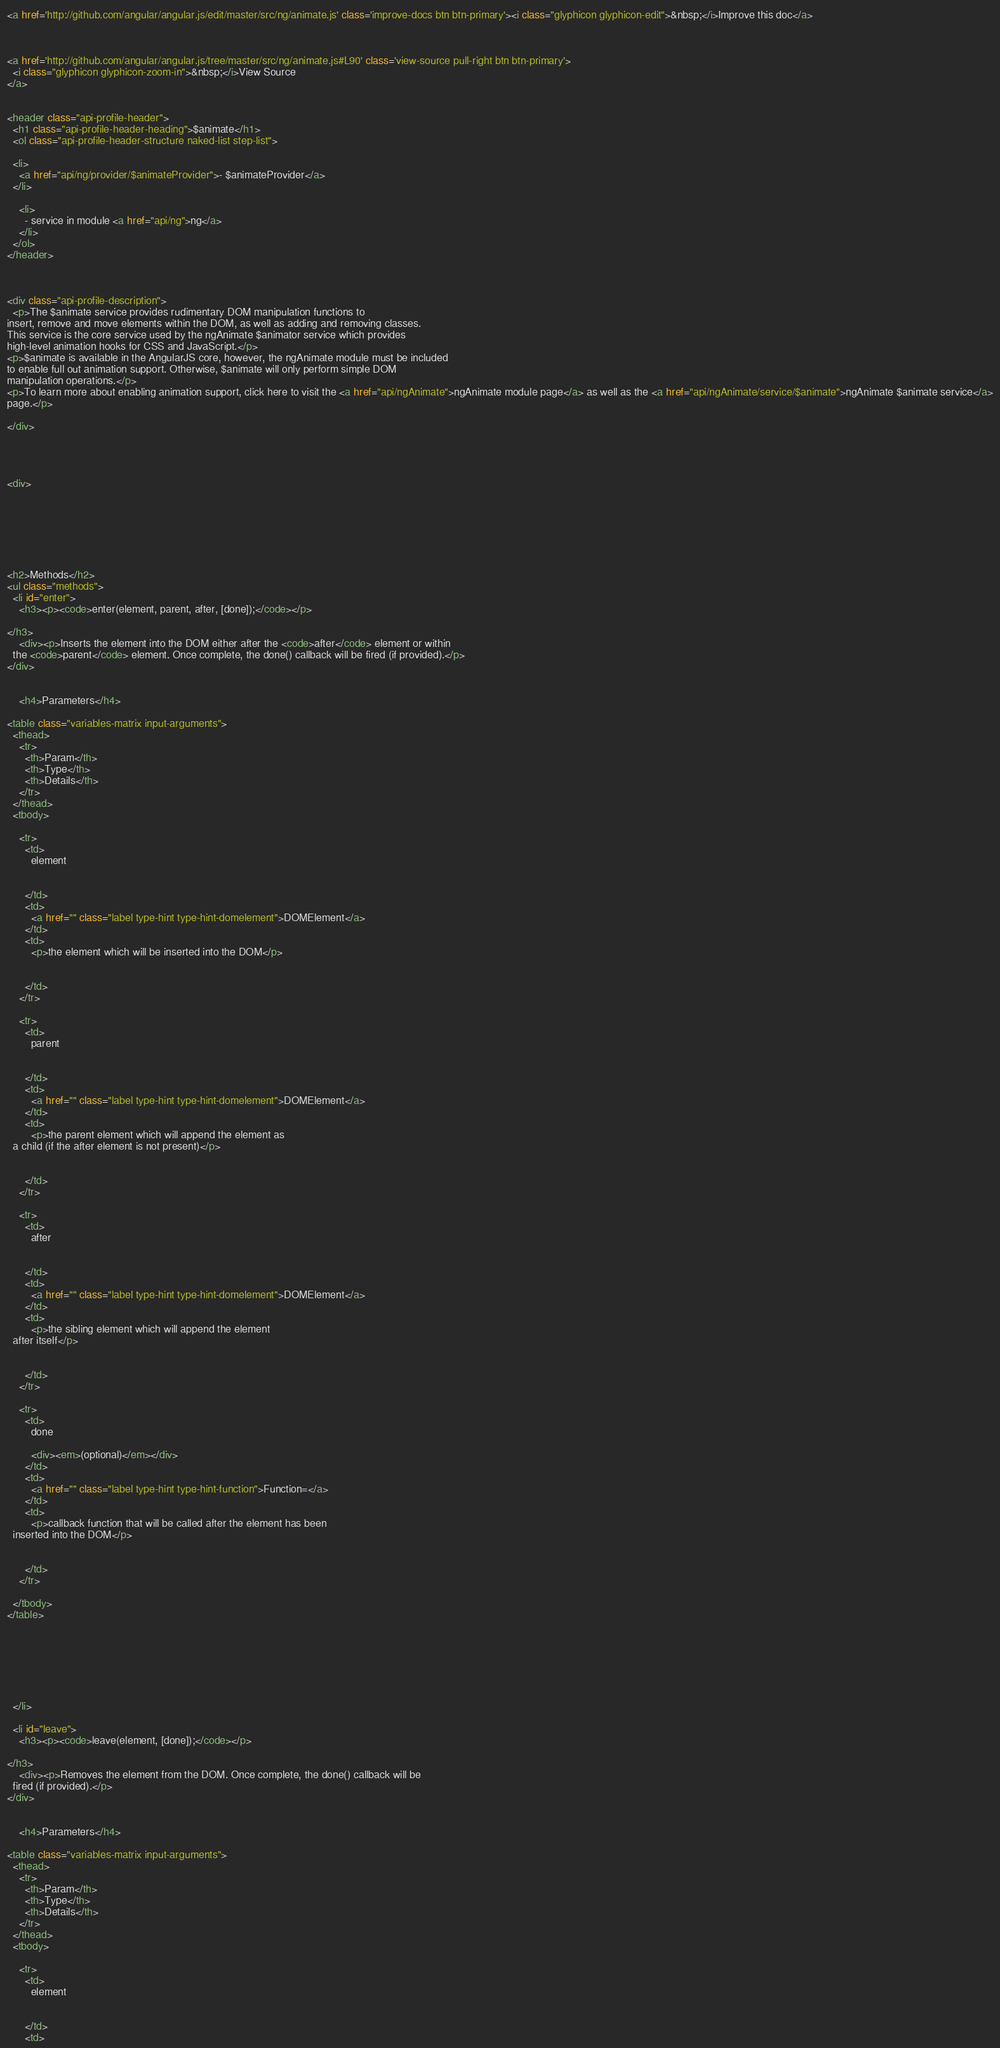Convert code to text. <code><loc_0><loc_0><loc_500><loc_500><_HTML_><a href='http://github.com/angular/angular.js/edit/master/src/ng/animate.js' class='improve-docs btn btn-primary'><i class="glyphicon glyphicon-edit">&nbsp;</i>Improve this doc</a>



<a href='http://github.com/angular/angular.js/tree/master/src/ng/animate.js#L90' class='view-source pull-right btn btn-primary'>
  <i class="glyphicon glyphicon-zoom-in">&nbsp;</i>View Source
</a>


<header class="api-profile-header">
  <h1 class="api-profile-header-heading">$animate</h1>
  <ol class="api-profile-header-structure naked-list step-list">
    
  <li>
    <a href="api/ng/provider/$animateProvider">- $animateProvider</a>
  </li>

    <li>
      - service in module <a href="api/ng">ng</a>
    </li>
  </ol>
</header>



<div class="api-profile-description">
  <p>The $animate service provides rudimentary DOM manipulation functions to
insert, remove and move elements within the DOM, as well as adding and removing classes.
This service is the core service used by the ngAnimate $animator service which provides
high-level animation hooks for CSS and JavaScript.</p>
<p>$animate is available in the AngularJS core, however, the ngAnimate module must be included
to enable full out animation support. Otherwise, $animate will only perform simple DOM
manipulation operations.</p>
<p>To learn more about enabling animation support, click here to visit the <a href="api/ngAnimate">ngAnimate module page</a> as well as the <a href="api/ngAnimate/service/$animate">ngAnimate $animate service</a>
page.</p>

</div>




<div>
  

    

  

  
<h2>Methods</h2>
<ul class="methods">
  <li id="enter">
    <h3><p><code>enter(element, parent, after, [done]);</code></p>

</h3>
    <div><p>Inserts the element into the DOM either after the <code>after</code> element or within
  the <code>parent</code> element. Once complete, the done() callback will be fired (if provided).</p>
</div>

    
    <h4>Parameters</h4>
    
<table class="variables-matrix input-arguments">
  <thead>
    <tr>
      <th>Param</th>
      <th>Type</th>
      <th>Details</th>
    </tr>
  </thead>
  <tbody>
    
    <tr>
      <td>
        element
        
        
      </td>
      <td>
        <a href="" class="label type-hint type-hint-domelement">DOMElement</a>
      </td>
      <td>
        <p>the element which will be inserted into the DOM</p>

        
      </td>
    </tr>
    
    <tr>
      <td>
        parent
        
        
      </td>
      <td>
        <a href="" class="label type-hint type-hint-domelement">DOMElement</a>
      </td>
      <td>
        <p>the parent element which will append the element as
  a child (if the after element is not present)</p>

        
      </td>
    </tr>
    
    <tr>
      <td>
        after
        
        
      </td>
      <td>
        <a href="" class="label type-hint type-hint-domelement">DOMElement</a>
      </td>
      <td>
        <p>the sibling element which will append the element
  after itself</p>

        
      </td>
    </tr>
    
    <tr>
      <td>
        done
        
        <div><em>(optional)</em></div>
      </td>
      <td>
        <a href="" class="label type-hint type-hint-function">Function=</a>
      </td>
      <td>
        <p>callback function that will be called after the element has been
  inserted into the DOM</p>

        
      </td>
    </tr>
    
  </tbody>
</table>

    

    
    
    

  </li>
  
  <li id="leave">
    <h3><p><code>leave(element, [done]);</code></p>

</h3>
    <div><p>Removes the element from the DOM. Once complete, the done() callback will be
  fired (if provided).</p>
</div>

    
    <h4>Parameters</h4>
    
<table class="variables-matrix input-arguments">
  <thead>
    <tr>
      <th>Param</th>
      <th>Type</th>
      <th>Details</th>
    </tr>
  </thead>
  <tbody>
    
    <tr>
      <td>
        element
        
        
      </td>
      <td></code> 